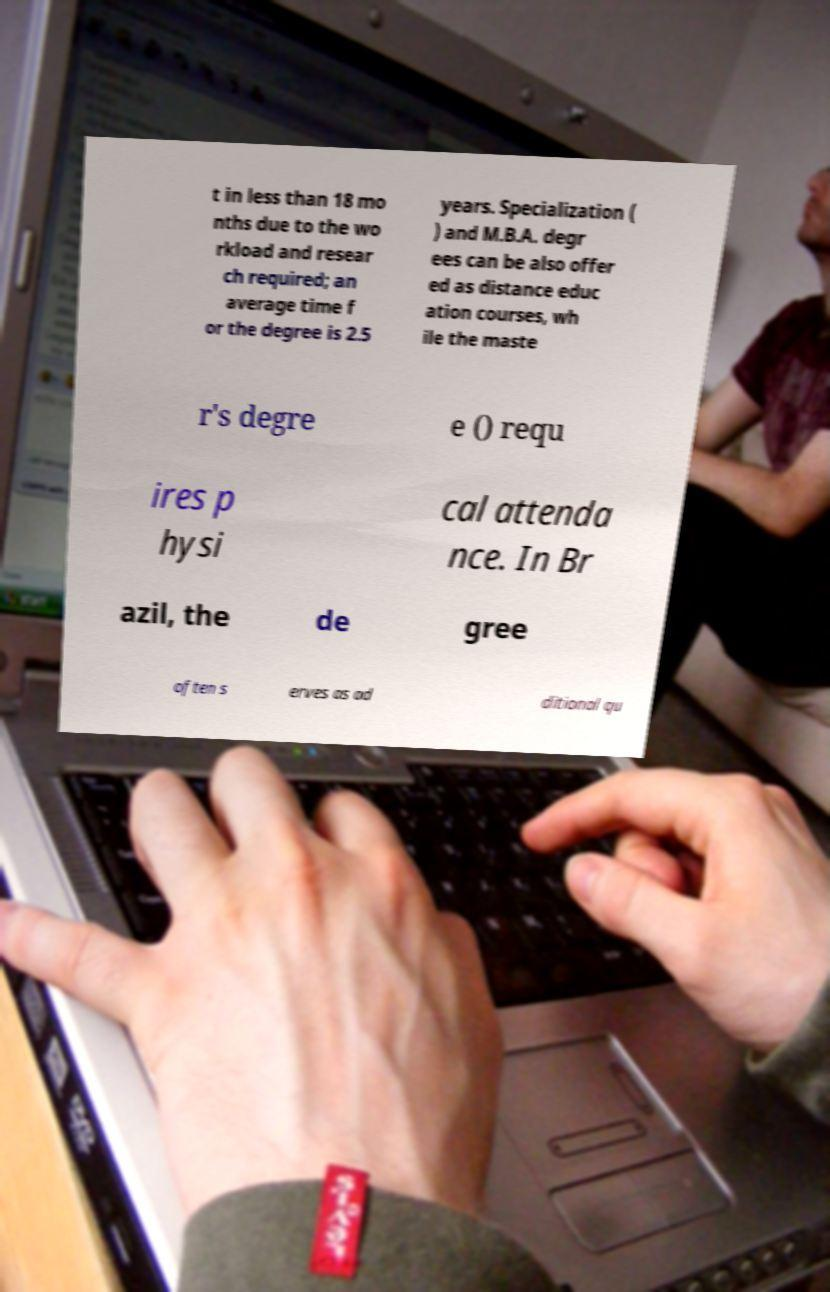I need the written content from this picture converted into text. Can you do that? t in less than 18 mo nths due to the wo rkload and resear ch required; an average time f or the degree is 2.5 years. Specialization ( ) and M.B.A. degr ees can be also offer ed as distance educ ation courses, wh ile the maste r's degre e () requ ires p hysi cal attenda nce. In Br azil, the de gree often s erves as ad ditional qu 